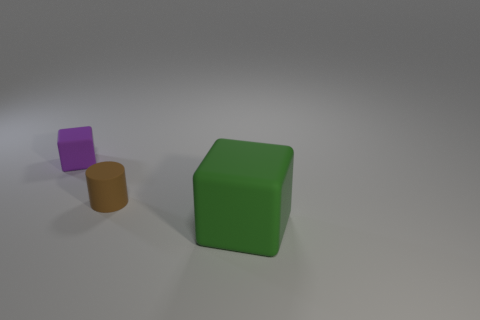Add 3 large green blocks. How many objects exist? 6 Subtract all cubes. How many objects are left? 1 Subtract 0 brown cubes. How many objects are left? 3 Subtract all purple rubber blocks. Subtract all purple blocks. How many objects are left? 1 Add 2 purple cubes. How many purple cubes are left? 3 Add 1 green blocks. How many green blocks exist? 2 